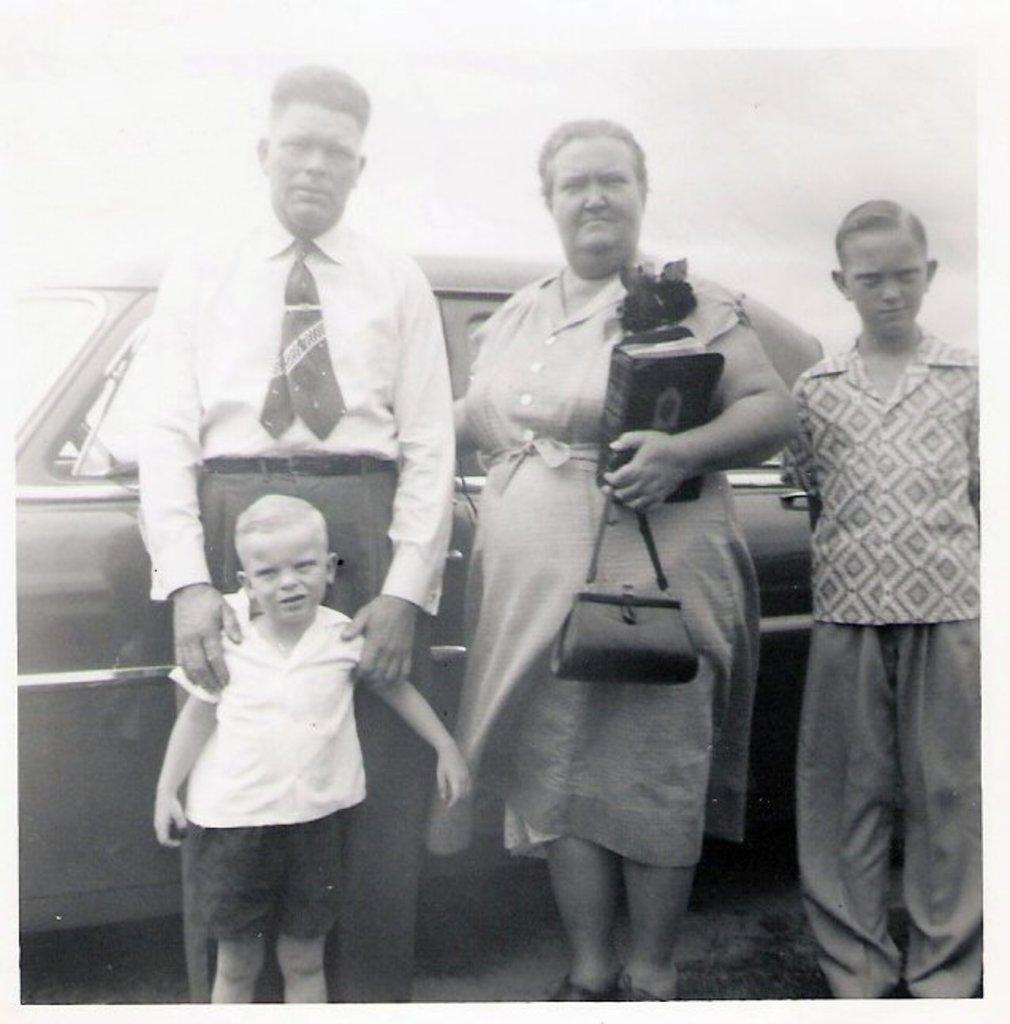How many people are in the image? There are people in the image. What are the people doing in the image? The people are standing near a car. Can you describe the woman in the middle of the image? The woman is in the middle of the image, and she is holding a book and a bag. What type of hen can be seen in the image? There is no hen present in the image. How does the woman feel about the book she is holding in the image? The image does not provide information about the woman's feelings or emotions. 